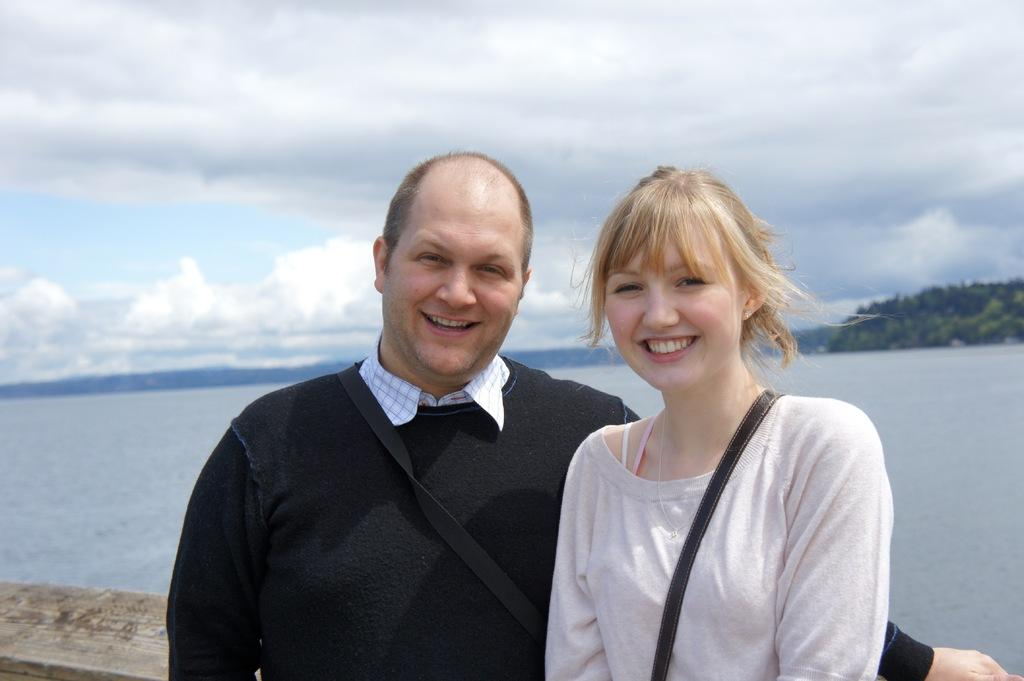How many people are present in the image? There are two people, a man and a woman, present in the image. What expressions do the man and the woman have? Both the man and the woman are smiling in the image. What can be seen in the background of the image? There is water, hills, and the sky visible in the background of the image. What type of natural environment is visible in the image? The natural environment includes water, hills, and the sky. Where is the zebra sitting in the image? There is no zebra present in the image. What type of measuring tool is used by the man in the image? There is no measuring tool visible in the image. 